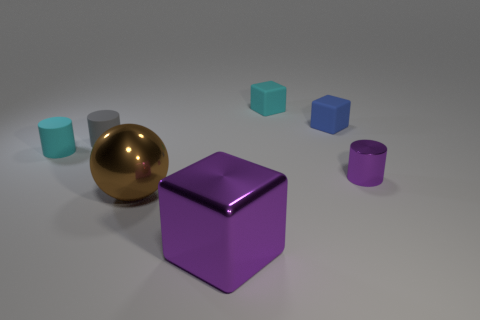Could you infer the sizes of these objects? Though the exact dimensions are not provided, the central purple cube and the gold sphere seem to be larger in comparison to the smaller blue and pink cubes, which suggest a varying scale of objects. 